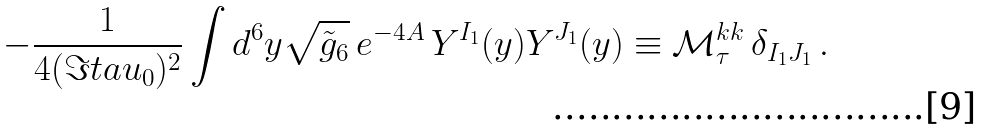Convert formula to latex. <formula><loc_0><loc_0><loc_500><loc_500>- \frac { 1 } { 4 ( \Im t a u _ { 0 } ) ^ { 2 } } \int d ^ { 6 } y \sqrt { \tilde { g } _ { 6 } } \, e ^ { - 4 A } \, Y ^ { I _ { 1 } } ( y ) Y ^ { J _ { 1 } } ( y ) \equiv \mathcal { M } ^ { k k } _ { \tau } \, \delta _ { I _ { 1 } J _ { 1 } } \, .</formula> 